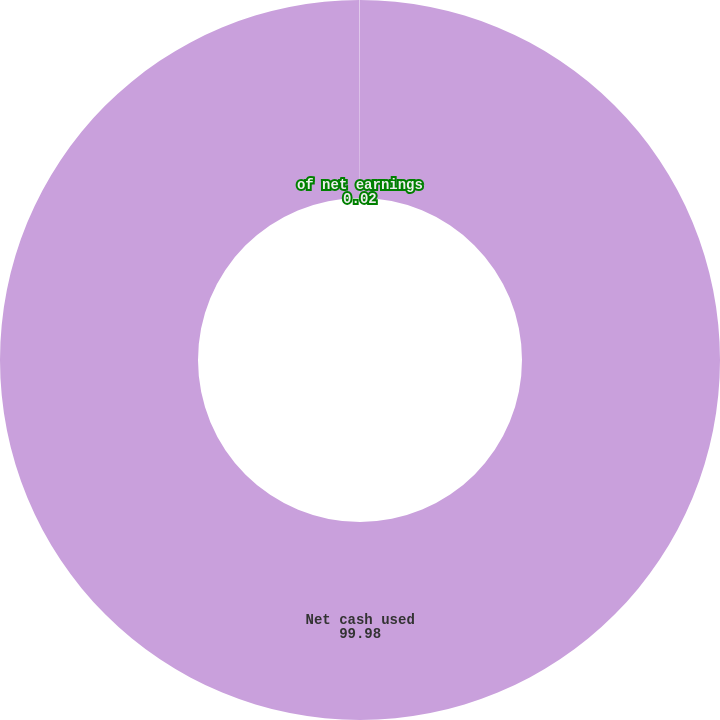<chart> <loc_0><loc_0><loc_500><loc_500><pie_chart><fcel>Net cash used<fcel>of net earnings<nl><fcel>99.98%<fcel>0.02%<nl></chart> 